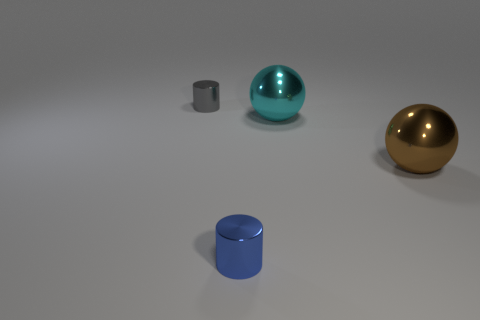There is a thing that is in front of the big thing in front of the big cyan metallic object; what number of large balls are left of it?
Ensure brevity in your answer.  0. Are there any other blue metal things that have the same shape as the blue thing?
Your answer should be very brief. No. What color is the other metal thing that is the same size as the cyan object?
Offer a terse response. Brown. How many objects are either big things behind the brown ball or tiny metallic cylinders that are in front of the cyan metal thing?
Your response must be concise. 2. What number of things are either large brown spheres or tiny blue metallic objects?
Give a very brief answer. 2. What size is the metal thing that is on the left side of the cyan shiny ball and behind the blue metal cylinder?
Offer a terse response. Small. What number of large cyan balls have the same material as the large cyan thing?
Keep it short and to the point. 0. The other cylinder that is made of the same material as the tiny gray cylinder is what color?
Give a very brief answer. Blue. There is a tiny thing that is in front of the tiny gray cylinder; what material is it?
Offer a terse response. Metal. Are there an equal number of tiny gray metallic cylinders that are on the left side of the small gray cylinder and purple shiny cylinders?
Offer a terse response. Yes. 